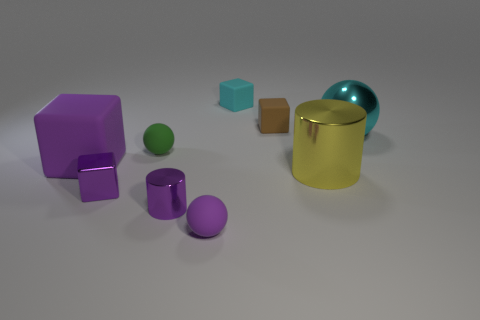Subtract all cubes. How many objects are left? 5 Add 3 small matte blocks. How many small matte blocks are left? 5 Add 5 small purple shiny balls. How many small purple shiny balls exist? 5 Subtract 0 brown cylinders. How many objects are left? 9 Subtract all red metallic things. Subtract all tiny matte spheres. How many objects are left? 7 